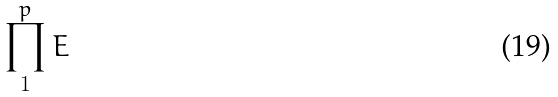<formula> <loc_0><loc_0><loc_500><loc_500>\prod _ { 1 } ^ { p } E</formula> 